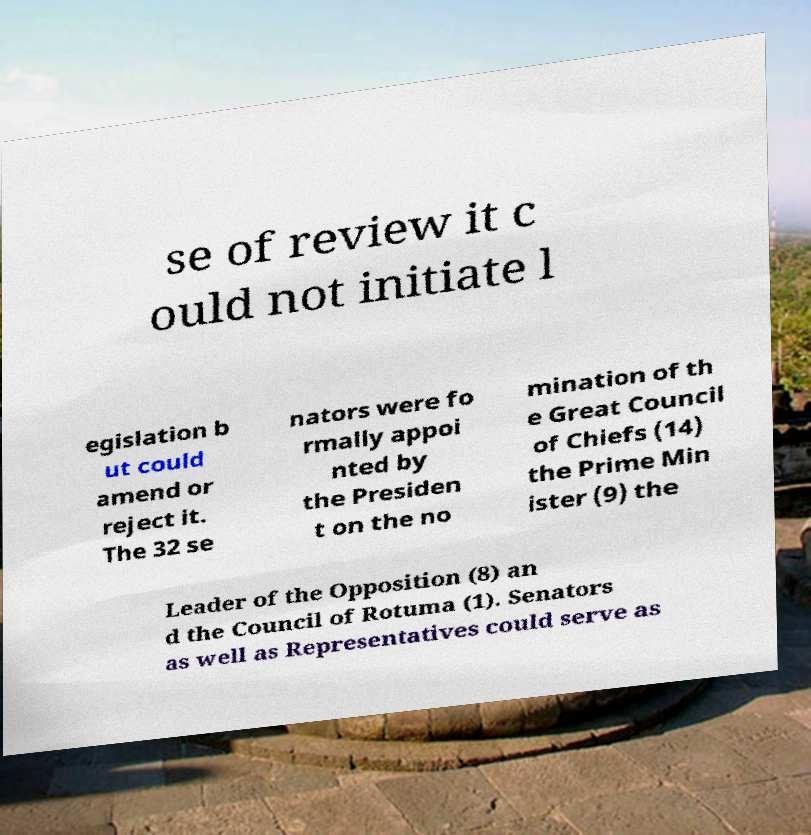Can you accurately transcribe the text from the provided image for me? se of review it c ould not initiate l egislation b ut could amend or reject it. The 32 se nators were fo rmally appoi nted by the Presiden t on the no mination of th e Great Council of Chiefs (14) the Prime Min ister (9) the Leader of the Opposition (8) an d the Council of Rotuma (1). Senators as well as Representatives could serve as 